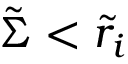<formula> <loc_0><loc_0><loc_500><loc_500>\tilde { \Sigma } < \tilde { r } _ { i }</formula> 